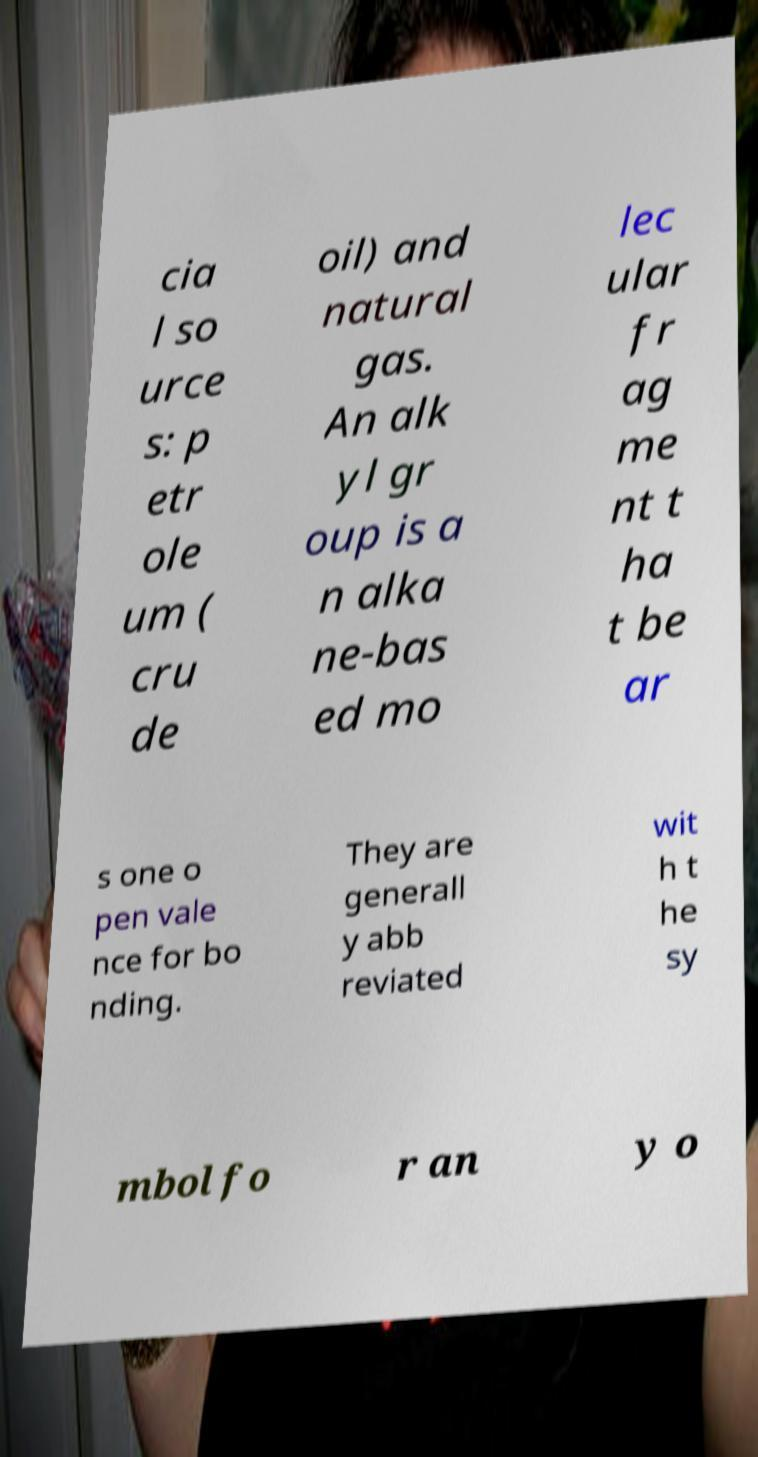For documentation purposes, I need the text within this image transcribed. Could you provide that? cia l so urce s: p etr ole um ( cru de oil) and natural gas. An alk yl gr oup is a n alka ne-bas ed mo lec ular fr ag me nt t ha t be ar s one o pen vale nce for bo nding. They are generall y abb reviated wit h t he sy mbol fo r an y o 